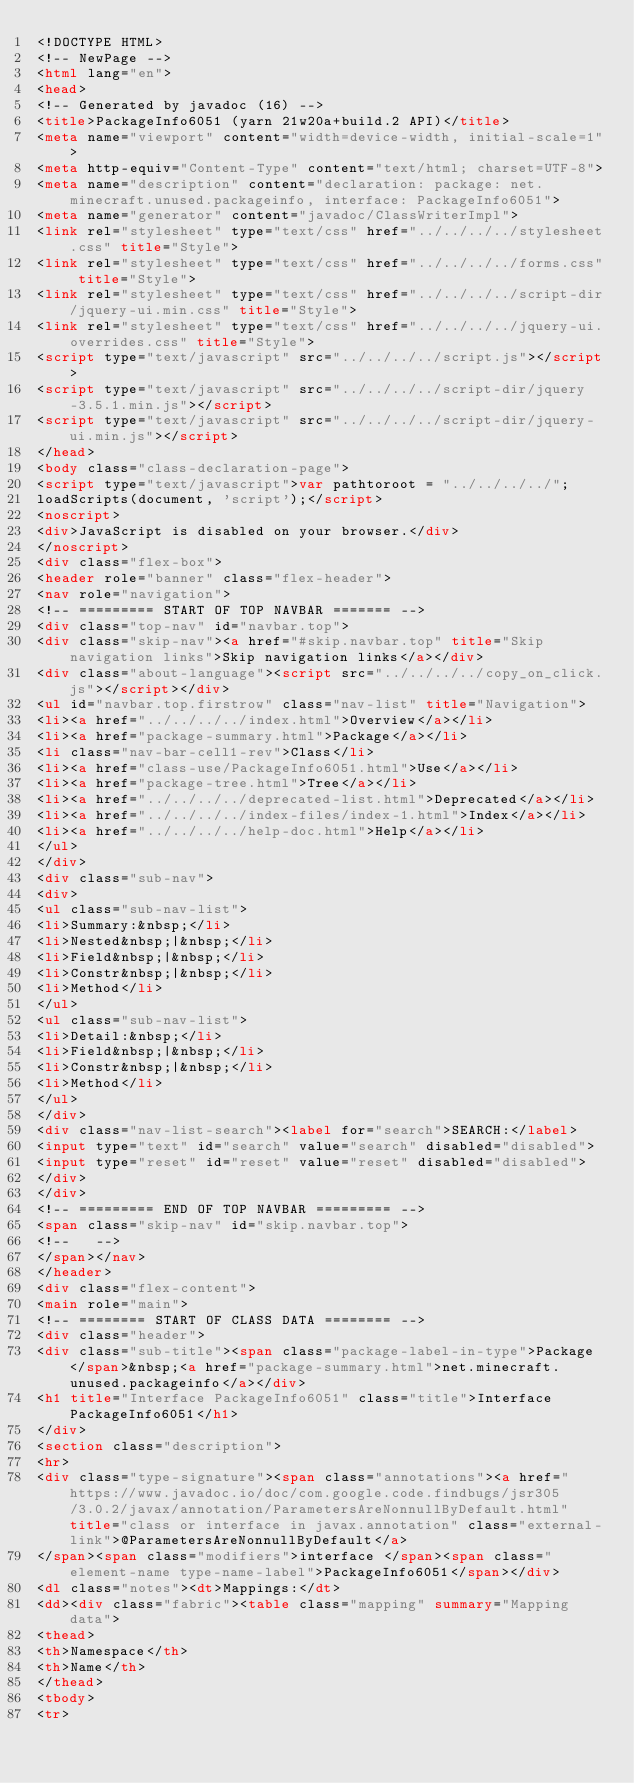Convert code to text. <code><loc_0><loc_0><loc_500><loc_500><_HTML_><!DOCTYPE HTML>
<!-- NewPage -->
<html lang="en">
<head>
<!-- Generated by javadoc (16) -->
<title>PackageInfo6051 (yarn 21w20a+build.2 API)</title>
<meta name="viewport" content="width=device-width, initial-scale=1">
<meta http-equiv="Content-Type" content="text/html; charset=UTF-8">
<meta name="description" content="declaration: package: net.minecraft.unused.packageinfo, interface: PackageInfo6051">
<meta name="generator" content="javadoc/ClassWriterImpl">
<link rel="stylesheet" type="text/css" href="../../../../stylesheet.css" title="Style">
<link rel="stylesheet" type="text/css" href="../../../../forms.css" title="Style">
<link rel="stylesheet" type="text/css" href="../../../../script-dir/jquery-ui.min.css" title="Style">
<link rel="stylesheet" type="text/css" href="../../../../jquery-ui.overrides.css" title="Style">
<script type="text/javascript" src="../../../../script.js"></script>
<script type="text/javascript" src="../../../../script-dir/jquery-3.5.1.min.js"></script>
<script type="text/javascript" src="../../../../script-dir/jquery-ui.min.js"></script>
</head>
<body class="class-declaration-page">
<script type="text/javascript">var pathtoroot = "../../../../";
loadScripts(document, 'script');</script>
<noscript>
<div>JavaScript is disabled on your browser.</div>
</noscript>
<div class="flex-box">
<header role="banner" class="flex-header">
<nav role="navigation">
<!-- ========= START OF TOP NAVBAR ======= -->
<div class="top-nav" id="navbar.top">
<div class="skip-nav"><a href="#skip.navbar.top" title="Skip navigation links">Skip navigation links</a></div>
<div class="about-language"><script src="../../../../copy_on_click.js"></script></div>
<ul id="navbar.top.firstrow" class="nav-list" title="Navigation">
<li><a href="../../../../index.html">Overview</a></li>
<li><a href="package-summary.html">Package</a></li>
<li class="nav-bar-cell1-rev">Class</li>
<li><a href="class-use/PackageInfo6051.html">Use</a></li>
<li><a href="package-tree.html">Tree</a></li>
<li><a href="../../../../deprecated-list.html">Deprecated</a></li>
<li><a href="../../../../index-files/index-1.html">Index</a></li>
<li><a href="../../../../help-doc.html">Help</a></li>
</ul>
</div>
<div class="sub-nav">
<div>
<ul class="sub-nav-list">
<li>Summary:&nbsp;</li>
<li>Nested&nbsp;|&nbsp;</li>
<li>Field&nbsp;|&nbsp;</li>
<li>Constr&nbsp;|&nbsp;</li>
<li>Method</li>
</ul>
<ul class="sub-nav-list">
<li>Detail:&nbsp;</li>
<li>Field&nbsp;|&nbsp;</li>
<li>Constr&nbsp;|&nbsp;</li>
<li>Method</li>
</ul>
</div>
<div class="nav-list-search"><label for="search">SEARCH:</label>
<input type="text" id="search" value="search" disabled="disabled">
<input type="reset" id="reset" value="reset" disabled="disabled">
</div>
</div>
<!-- ========= END OF TOP NAVBAR ========= -->
<span class="skip-nav" id="skip.navbar.top">
<!--   -->
</span></nav>
</header>
<div class="flex-content">
<main role="main">
<!-- ======== START OF CLASS DATA ======== -->
<div class="header">
<div class="sub-title"><span class="package-label-in-type">Package</span>&nbsp;<a href="package-summary.html">net.minecraft.unused.packageinfo</a></div>
<h1 title="Interface PackageInfo6051" class="title">Interface PackageInfo6051</h1>
</div>
<section class="description">
<hr>
<div class="type-signature"><span class="annotations"><a href="https://www.javadoc.io/doc/com.google.code.findbugs/jsr305/3.0.2/javax/annotation/ParametersAreNonnullByDefault.html" title="class or interface in javax.annotation" class="external-link">@ParametersAreNonnullByDefault</a>
</span><span class="modifiers">interface </span><span class="element-name type-name-label">PackageInfo6051</span></div>
<dl class="notes"><dt>Mappings:</dt>
<dd><div class="fabric"><table class="mapping" summary="Mapping data">
<thead>
<th>Namespace</th>
<th>Name</th>
</thead>
<tbody>
<tr></code> 